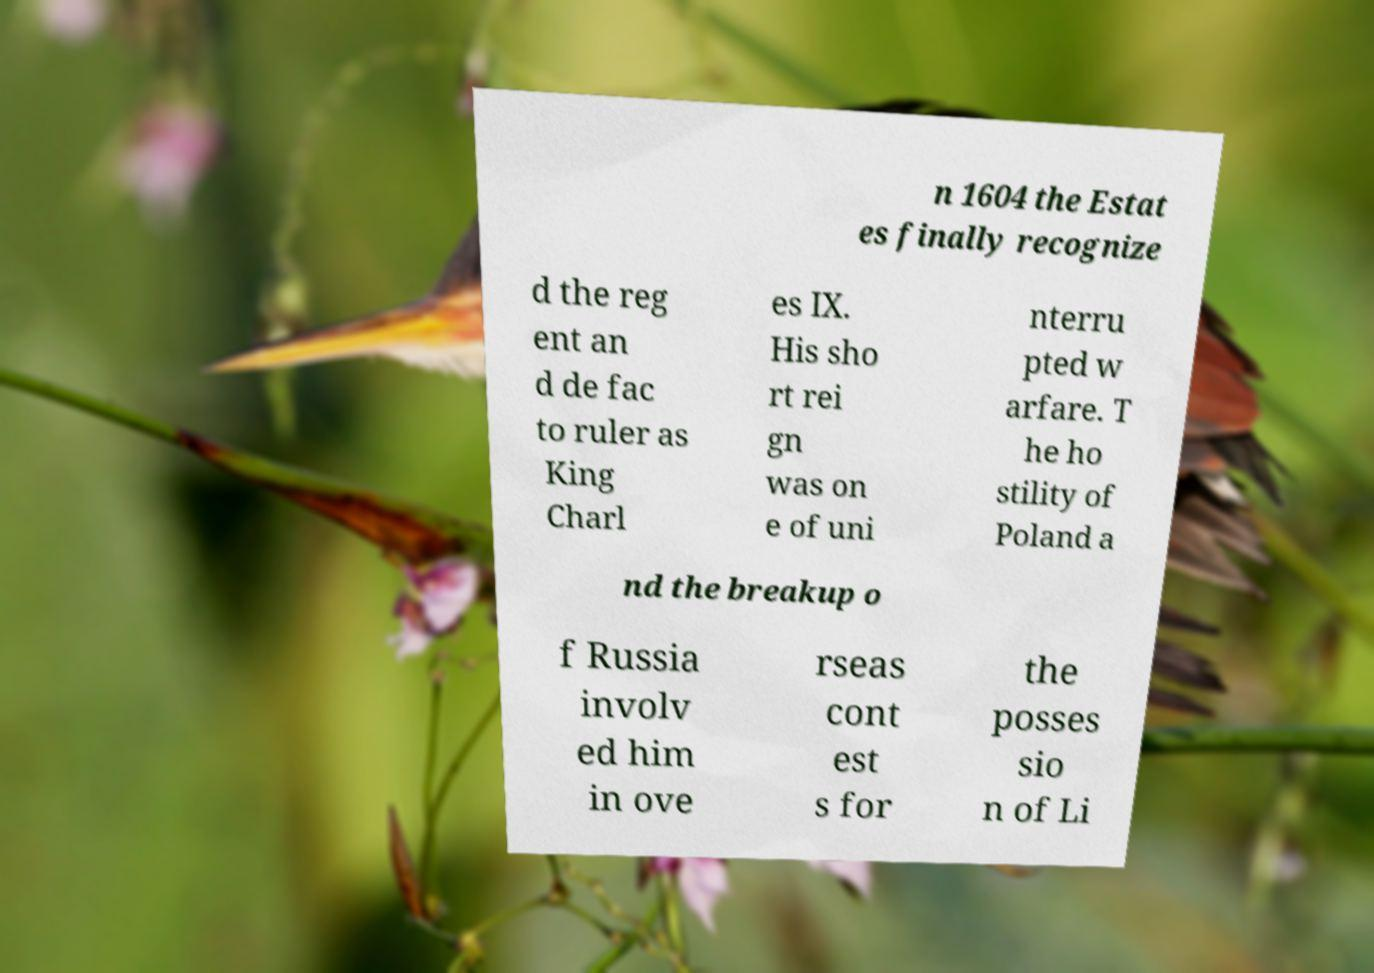Could you assist in decoding the text presented in this image and type it out clearly? n 1604 the Estat es finally recognize d the reg ent an d de fac to ruler as King Charl es IX. His sho rt rei gn was on e of uni nterru pted w arfare. T he ho stility of Poland a nd the breakup o f Russia involv ed him in ove rseas cont est s for the posses sio n of Li 